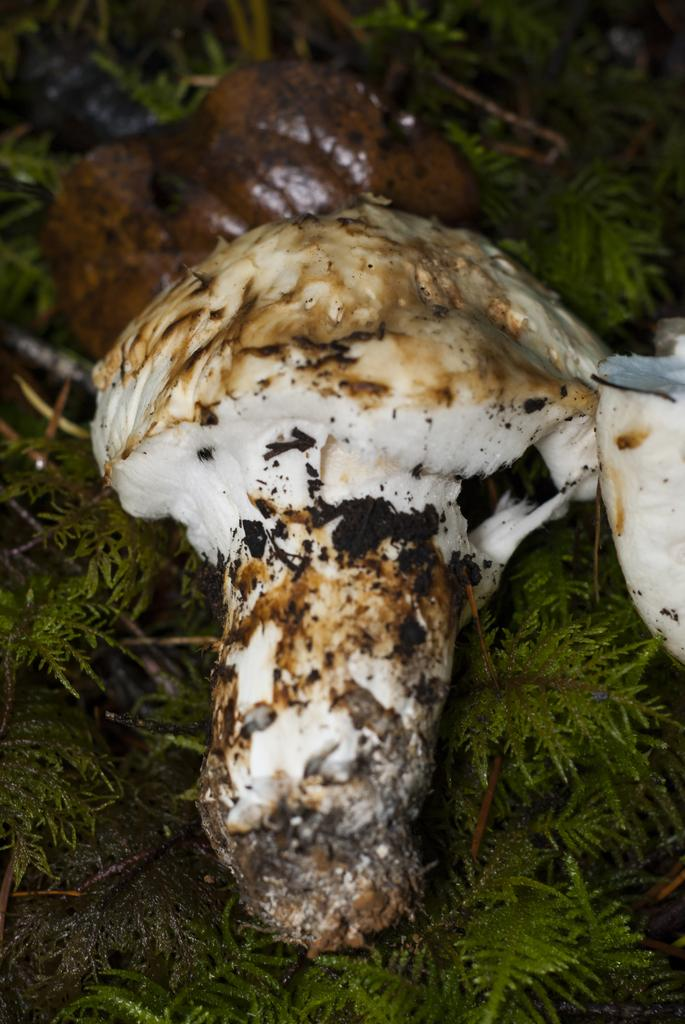What is the main subject in the image? There is a mushroom in the image. What type of vegetation can be seen behind the mushroom? There is grass visible behind the mushroom in the image. What color is the crayon used to draw the mushroom in the image? There is no crayon or drawing present in the image; it is a photograph of a real mushroom. What position is the cabbage in the image? There is no cabbage present in the image. 